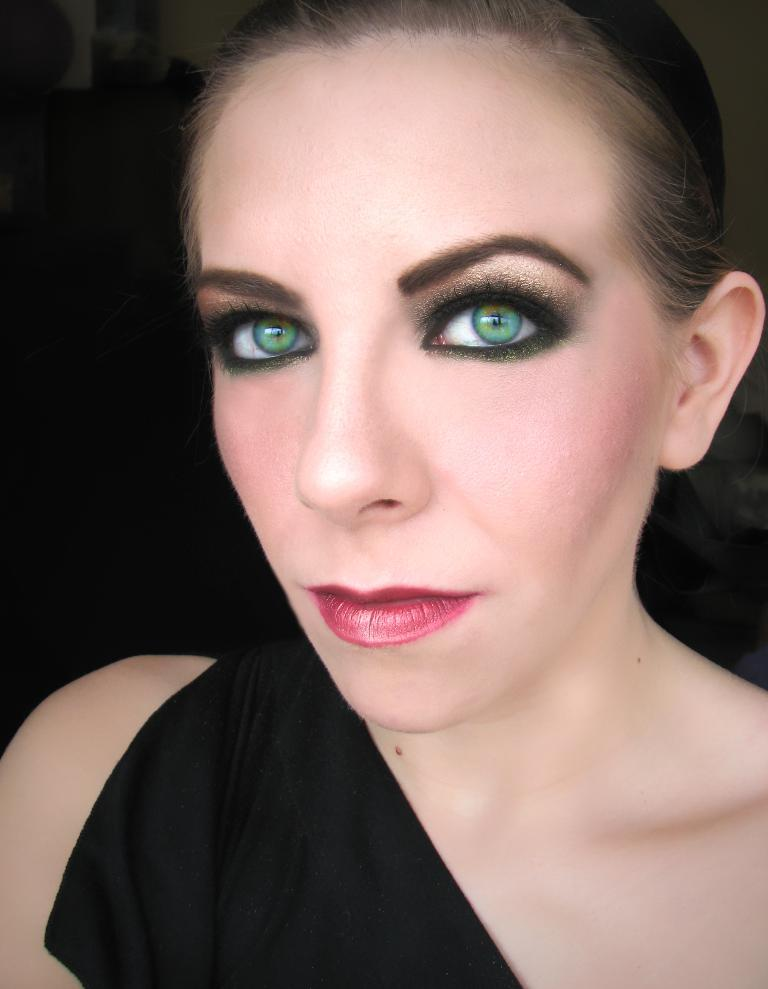Who or what is the main subject of the image? There is a person in the image. What is the person wearing? The person is wearing a black dress. What can be seen in the background of the image? The background of the image is dark. What type of bridge can be seen in the background of the image? There is no bridge present in the image; the background is dark. Is there a stage visible in the image? There is no mention of a stage in the provided facts, so we cannot assume the presence of a stage in the image. We focus on the information given and formulate questions that can be answered definitively based on the facts. We avoid making assumptions and ensure that the language is simple and clear. --- Facts: 1. There is a car in the image. 2. The car is red. 3. The car has four wheels. 4. There are people in the car. 5. The car is parked on the street. Absurd Topics: parrot, ocean, mountain Conversation: What is the main subject of the image? The main subject of the image is a car. What color is the car? The car is red. How many wheels does the car have? The car has four wheels. Are there any passengers in the car? Yes, there are people in the car. Where is the car located in the image? The car is parked on the street. Reasoning: Let's think step by step in order to produce the conversation. We start by identifying the main subject of the image, which is the car. Then, we describe the car's color, noting that it is red. Next, we mention the number of wheels the car has, which is four. We then acknowledge the presence of passengers by stating that there are people in the car. Finally, we describe the car's location, which is parked on the street. Absurd Question/Answer: Can you see a parrot flying over the ocean in the background of the image? There is no parrot or ocean present in the image; it features a red car parked on the street. Is there a mountain visible in the image? There is no mountain present in the image; it features a red car parked on the street. 